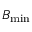Convert formula to latex. <formula><loc_0><loc_0><loc_500><loc_500>B _ { \min }</formula> 